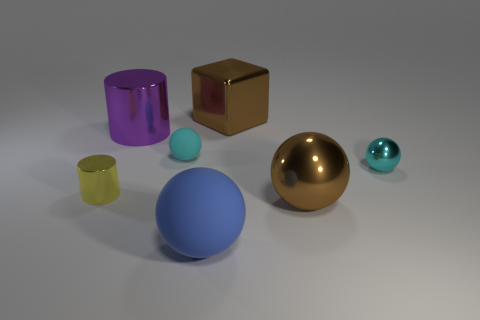There is a large ball that is the same color as the large shiny cube; what is it made of?
Make the answer very short. Metal. Are there any shiny things on the left side of the blue sphere?
Your answer should be very brief. Yes. Is there any other thing that has the same color as the big matte object?
Keep it short and to the point. No. How many cylinders are either big purple shiny things or shiny objects?
Provide a succinct answer. 2. What number of metal objects are on the right side of the big purple metal object and in front of the large purple shiny thing?
Offer a very short reply. 2. Are there the same number of objects that are in front of the cyan matte ball and blue spheres that are right of the tiny cyan metallic object?
Provide a short and direct response. No. Do the big brown thing in front of the small yellow cylinder and the small rubber object have the same shape?
Make the answer very short. Yes. The brown metallic object that is in front of the brown object behind the big shiny thing that is on the right side of the brown block is what shape?
Your response must be concise. Sphere. There is a thing that is the same color as the large metal cube; what is its shape?
Offer a very short reply. Sphere. There is a large object that is in front of the purple metal object and on the left side of the shiny cube; what material is it made of?
Provide a short and direct response. Rubber. 